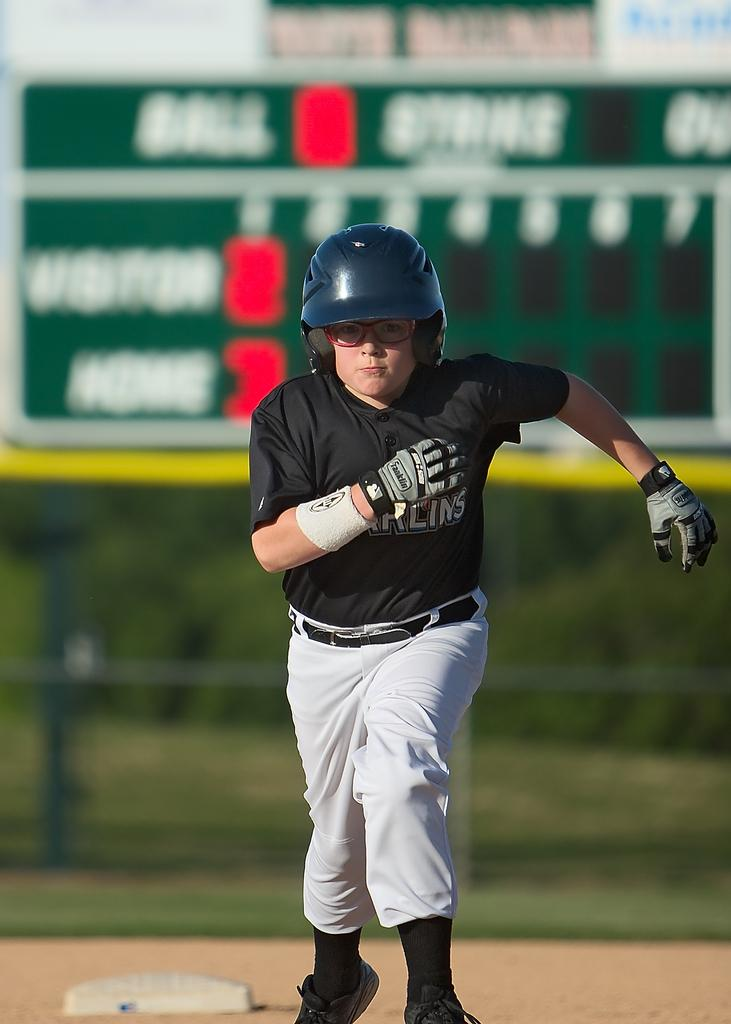<image>
Give a short and clear explanation of the subsequent image. A baseball player for the Marlins is running bases 